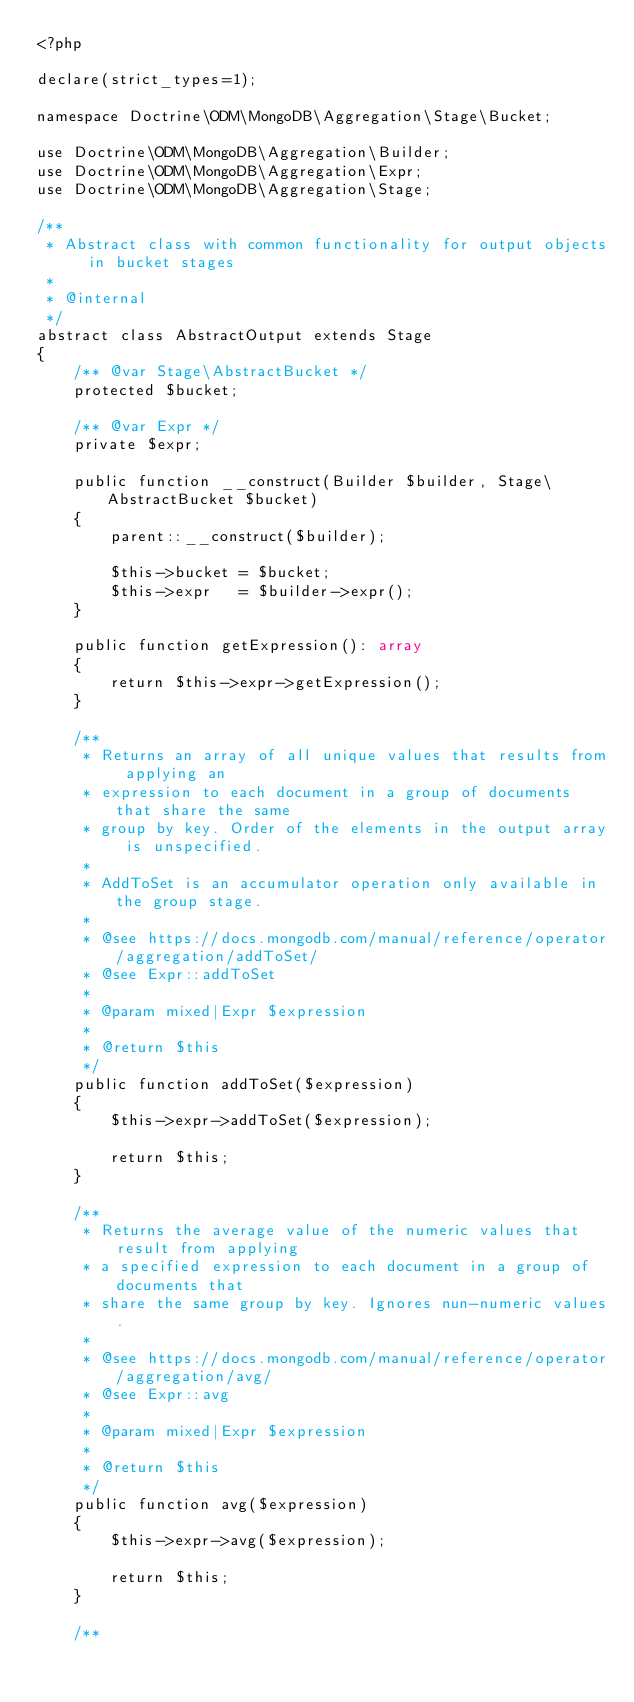Convert code to text. <code><loc_0><loc_0><loc_500><loc_500><_PHP_><?php

declare(strict_types=1);

namespace Doctrine\ODM\MongoDB\Aggregation\Stage\Bucket;

use Doctrine\ODM\MongoDB\Aggregation\Builder;
use Doctrine\ODM\MongoDB\Aggregation\Expr;
use Doctrine\ODM\MongoDB\Aggregation\Stage;

/**
 * Abstract class with common functionality for output objects in bucket stages
 *
 * @internal
 */
abstract class AbstractOutput extends Stage
{
    /** @var Stage\AbstractBucket */
    protected $bucket;

    /** @var Expr */
    private $expr;

    public function __construct(Builder $builder, Stage\AbstractBucket $bucket)
    {
        parent::__construct($builder);

        $this->bucket = $bucket;
        $this->expr   = $builder->expr();
    }

    public function getExpression(): array
    {
        return $this->expr->getExpression();
    }

    /**
     * Returns an array of all unique values that results from applying an
     * expression to each document in a group of documents that share the same
     * group by key. Order of the elements in the output array is unspecified.
     *
     * AddToSet is an accumulator operation only available in the group stage.
     *
     * @see https://docs.mongodb.com/manual/reference/operator/aggregation/addToSet/
     * @see Expr::addToSet
     *
     * @param mixed|Expr $expression
     *
     * @return $this
     */
    public function addToSet($expression)
    {
        $this->expr->addToSet($expression);

        return $this;
    }

    /**
     * Returns the average value of the numeric values that result from applying
     * a specified expression to each document in a group of documents that
     * share the same group by key. Ignores nun-numeric values.
     *
     * @see https://docs.mongodb.com/manual/reference/operator/aggregation/avg/
     * @see Expr::avg
     *
     * @param mixed|Expr $expression
     *
     * @return $this
     */
    public function avg($expression)
    {
        $this->expr->avg($expression);

        return $this;
    }

    /**</code> 